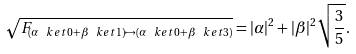<formula> <loc_0><loc_0><loc_500><loc_500>\sqrt { F _ { ( \alpha \ k e t { 0 } + \beta \ k e t { 1 } ) \mapsto ( \alpha \ k e t { 0 } + \beta \ k e t { 3 } ) } } = | \alpha | ^ { 2 } + | \beta | ^ { 2 } \sqrt { \frac { 3 } { 5 } } .</formula> 